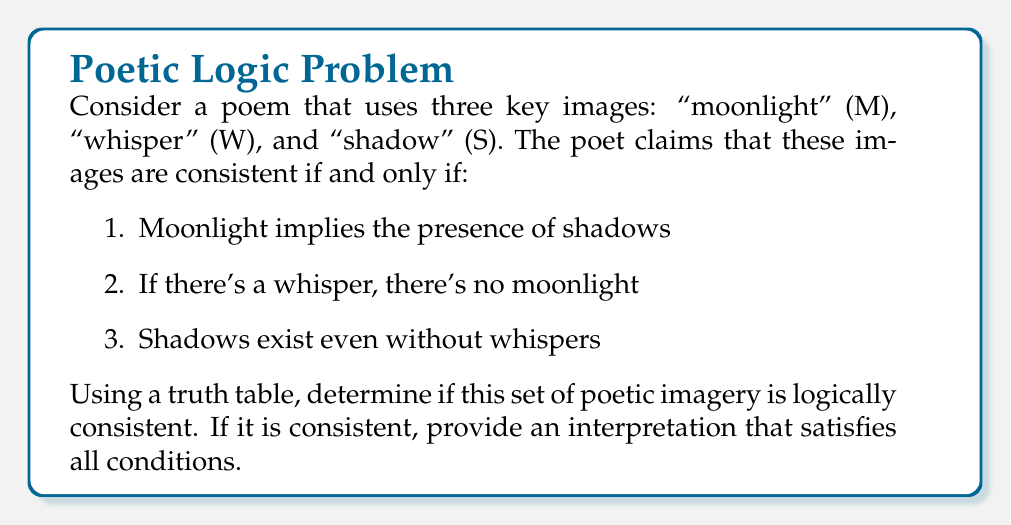Help me with this question. To evaluate the consistency of the poetic imagery, we need to construct a truth table and check if there's at least one row where all conditions are true simultaneously.

Let's define the logical statements:
1. $M \rightarrow S$
2. $W \rightarrow \neg M$
3. $S \vee \neg W$

We'll create a truth table with all possible combinations of M, W, and S:

$$
\begin{array}{|c|c|c||c|c|c|c|}
\hline
M & W & S & M \rightarrow S & W \rightarrow \neg M & S \vee \neg W & \text{All True?} \\
\hline
T & T & T & T & F & T & F \\
T & T & F & F & F & F & F \\
T & F & T & T & T & T & T \\
T & F & F & F & T & T & F \\
F & T & T & T & T & T & T \\
F & T & F & T & T & F & F \\
F & F & T & T & T & T & T \\
F & F & F & T & T & T & T \\
\hline
\end{array}
$$

We can see that there are four rows where all conditions are true simultaneously:
1. M = T, W = F, S = T
2. M = F, W = T, S = T
3. M = F, W = F, S = T
4. M = F, W = F, S = F

This means the set of poetic imagery is logically consistent. We can provide an interpretation that satisfies all conditions:

"In the absence of whispers (W = F), moonlight (M = T) casts shadows (S = T). Alternatively, when there are whispers (W = T), the moonlight fades (M = F), but shadows persist (S = T). Even in complete stillness, with no moonlight or whispers (M = F, W = F), shadows may or may not exist (S = T or F), representing the ambiguity and depth of the poetic imagery."
Answer: The set of poetic imagery is logically consistent. There are four interpretations that satisfy all conditions, with the most poetically rich being: M = T, W = F, S = T, representing a scene of silent moonlight casting shadows. 